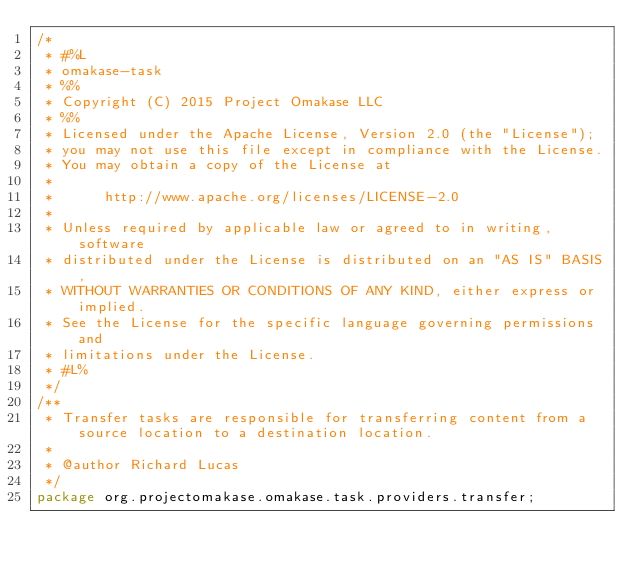Convert code to text. <code><loc_0><loc_0><loc_500><loc_500><_Java_>/*
 * #%L
 * omakase-task
 * %%
 * Copyright (C) 2015 Project Omakase LLC
 * %%
 * Licensed under the Apache License, Version 2.0 (the "License");
 * you may not use this file except in compliance with the License.
 * You may obtain a copy of the License at
 * 
 *      http://www.apache.org/licenses/LICENSE-2.0
 * 
 * Unless required by applicable law or agreed to in writing, software
 * distributed under the License is distributed on an "AS IS" BASIS,
 * WITHOUT WARRANTIES OR CONDITIONS OF ANY KIND, either express or implied.
 * See the License for the specific language governing permissions and
 * limitations under the License.
 * #L%
 */
/**
 * Transfer tasks are responsible for transferring content from a source location to a destination location.
 *
 * @author Richard Lucas
 */
package org.projectomakase.omakase.task.providers.transfer;</code> 